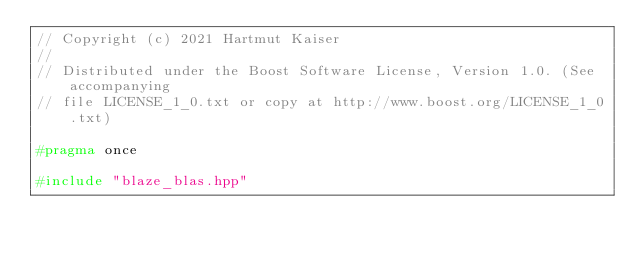Convert code to text. <code><loc_0><loc_0><loc_500><loc_500><_C++_>// Copyright (c) 2021 Hartmut Kaiser
//
// Distributed under the Boost Software License, Version 1.0. (See accompanying
// file LICENSE_1_0.txt or copy at http://www.boost.org/LICENSE_1_0.txt)

#pragma once

#include "blaze_blas.hpp"
</code> 